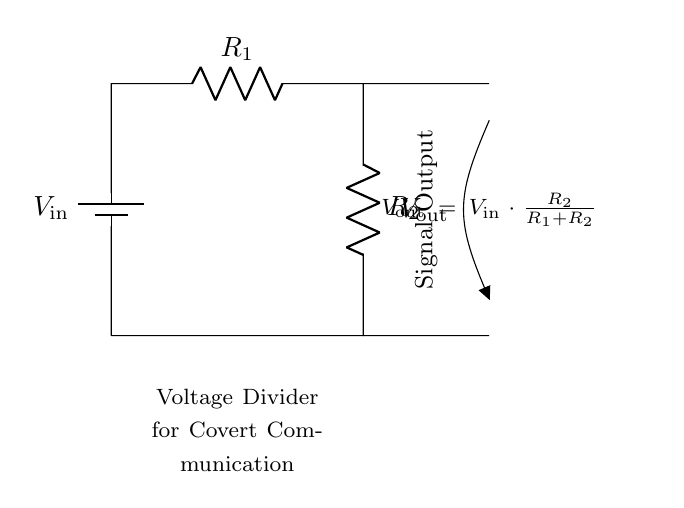What is the input voltage in this circuit? The input voltage is denoted as V_in, which is the voltage supplied to the circuit from the battery.
Answer: V_in What are the resistances used in the voltage divider? The resistances used are R_1 and R_2, which are labeled in the circuit diagram.
Answer: R_1, R_2 What is the formula for the output voltage? The formula for the output voltage V_out is given by the equation V_out = V_in * (R_2 / (R_1 + R_2)), which shows how V_out is calculated based on the resistances and input voltage.
Answer: V_out = V_in * (R_2 / (R_1 + R_2)) How does R_2 affect the output voltage? R_2 affects the output voltage as a larger value of R_2 will increase V_out if V_in is held constant, due to the voltage divider principle.
Answer: Increases V_out If R_1 is increased with R_2 constant, what happens to V_out? Increasing R_1 while keeping R_2 constant will decrease V_out because the ratio R_2 / (R_1 + R_2) becomes smaller, leading to a lower output voltage for the same input voltage V_in.
Answer: Decreases V_out What role does the entire circuit play in covert communication? The voltage divider adjusts the signal strength, which is essential in covert communication to maintain the integrity of the signal while preventing detection.
Answer: Adjusts signal strength 